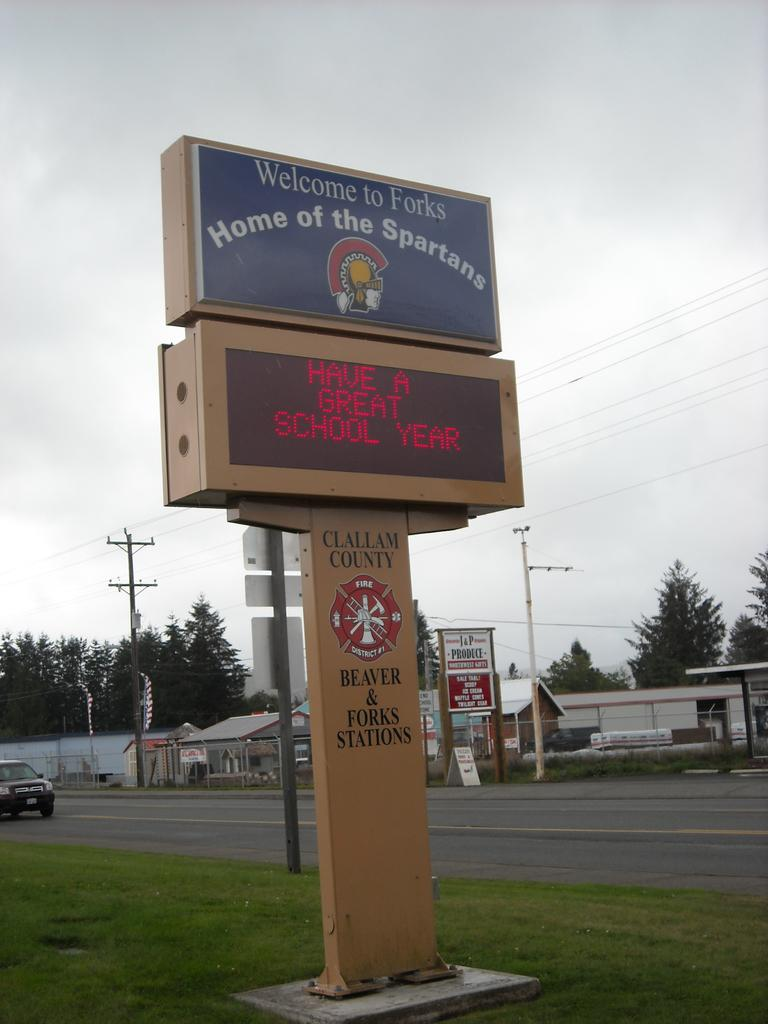<image>
Share a concise interpretation of the image provided. Welcome to the home of the spartans sign above a Have a great school year sign. 